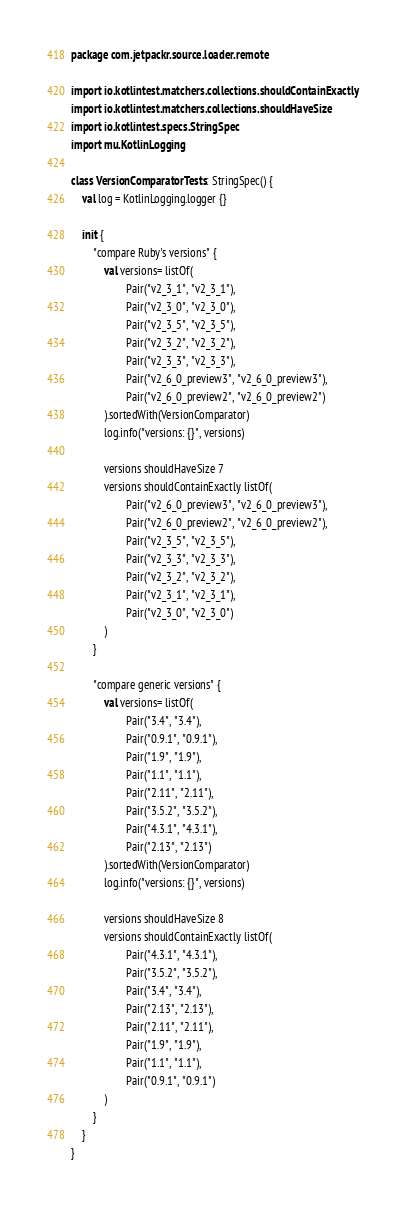Convert code to text. <code><loc_0><loc_0><loc_500><loc_500><_Kotlin_>package com.jetpackr.source.loader.remote

import io.kotlintest.matchers.collections.shouldContainExactly
import io.kotlintest.matchers.collections.shouldHaveSize
import io.kotlintest.specs.StringSpec
import mu.KotlinLogging

class VersionComparatorTests : StringSpec() {
    val log = KotlinLogging.logger {}

    init {
        "compare Ruby's versions" {
            val versions= listOf(
                    Pair("v2_3_1", "v2_3_1"),
                    Pair("v2_3_0", "v2_3_0"),
                    Pair("v2_3_5", "v2_3_5"),
                    Pair("v2_3_2", "v2_3_2"),
                    Pair("v2_3_3", "v2_3_3"),
                    Pair("v2_6_0_preview3", "v2_6_0_preview3"),
                    Pair("v2_6_0_preview2", "v2_6_0_preview2")
            ).sortedWith(VersionComparator)
            log.info("versions: {}", versions)

            versions shouldHaveSize 7
            versions shouldContainExactly listOf(
                    Pair("v2_6_0_preview3", "v2_6_0_preview3"),
                    Pair("v2_6_0_preview2", "v2_6_0_preview2"),
                    Pair("v2_3_5", "v2_3_5"),
                    Pair("v2_3_3", "v2_3_3"),
                    Pair("v2_3_2", "v2_3_2"),
                    Pair("v2_3_1", "v2_3_1"),
                    Pair("v2_3_0", "v2_3_0")
            )
        }

        "compare generic versions" {
            val versions= listOf(
                    Pair("3.4", "3.4"),
                    Pair("0.9.1", "0.9.1"),
                    Pair("1.9", "1.9"),
                    Pair("1.1", "1.1"),
                    Pair("2.11", "2.11"),
                    Pair("3.5.2", "3.5.2"),
                    Pair("4.3.1", "4.3.1"),
                    Pair("2.13", "2.13")
            ).sortedWith(VersionComparator)
            log.info("versions: {}", versions)

            versions shouldHaveSize 8
            versions shouldContainExactly listOf(
                    Pair("4.3.1", "4.3.1"),
                    Pair("3.5.2", "3.5.2"),
                    Pair("3.4", "3.4"),
                    Pair("2.13", "2.13"),
                    Pair("2.11", "2.11"),
                    Pair("1.9", "1.9"),
                    Pair("1.1", "1.1"),
                    Pair("0.9.1", "0.9.1")
            )
        }
    }
}</code> 